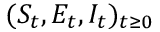<formula> <loc_0><loc_0><loc_500><loc_500>( S _ { t } , E _ { t } , I _ { t } ) _ { t \geq 0 }</formula> 